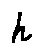Convert formula to latex. <formula><loc_0><loc_0><loc_500><loc_500>h</formula> 